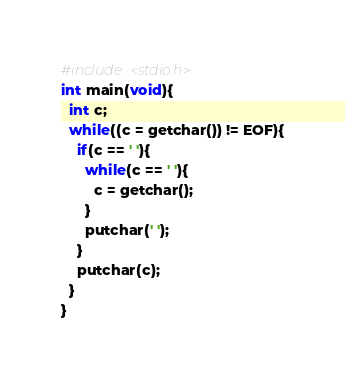Convert code to text. <code><loc_0><loc_0><loc_500><loc_500><_C_>#include <stdio.h>
int main(void){
  int c;
  while((c = getchar()) != EOF){
    if(c == ' '){
      while(c == ' '){
        c = getchar();
      }
      putchar(' ');
    }
    putchar(c);
  }
}
</code> 